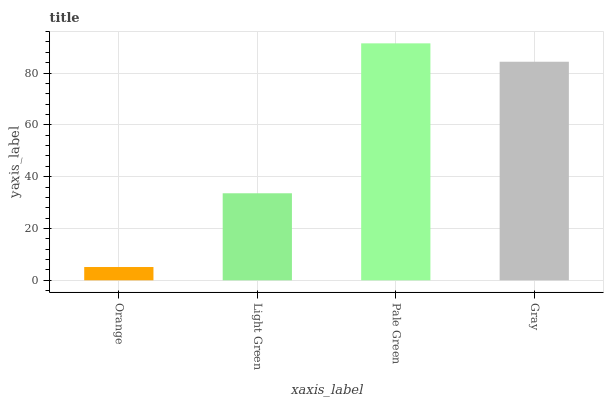Is Light Green the minimum?
Answer yes or no. No. Is Light Green the maximum?
Answer yes or no. No. Is Light Green greater than Orange?
Answer yes or no. Yes. Is Orange less than Light Green?
Answer yes or no. Yes. Is Orange greater than Light Green?
Answer yes or no. No. Is Light Green less than Orange?
Answer yes or no. No. Is Gray the high median?
Answer yes or no. Yes. Is Light Green the low median?
Answer yes or no. Yes. Is Pale Green the high median?
Answer yes or no. No. Is Gray the low median?
Answer yes or no. No. 